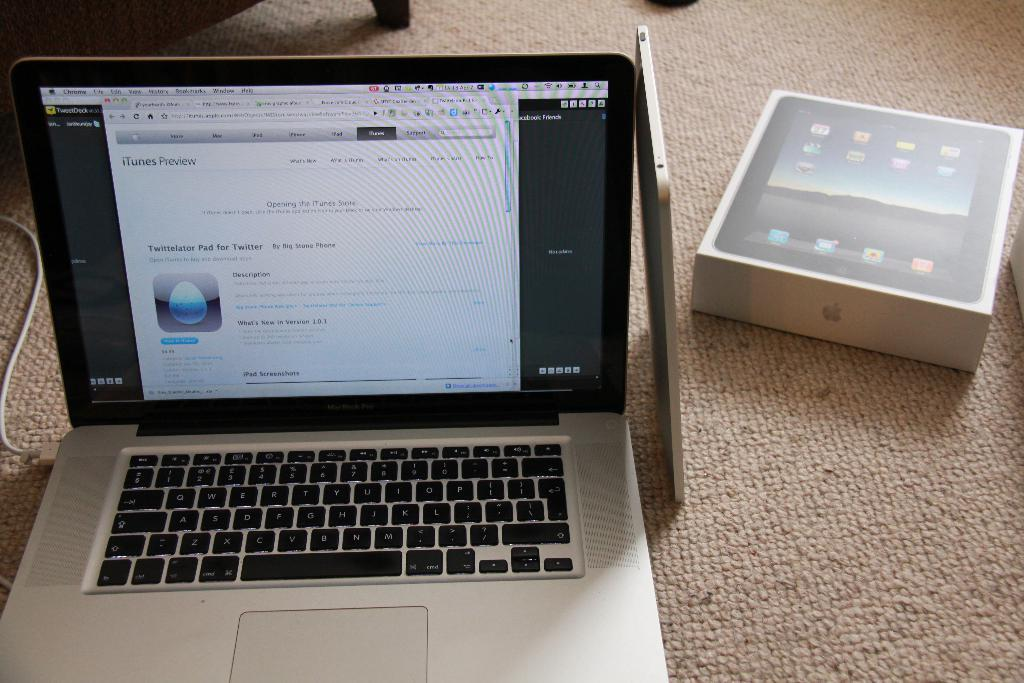<image>
Summarize the visual content of the image. A Macbook shows a screen for an app called Twittelator Pad for Twitter on it. 